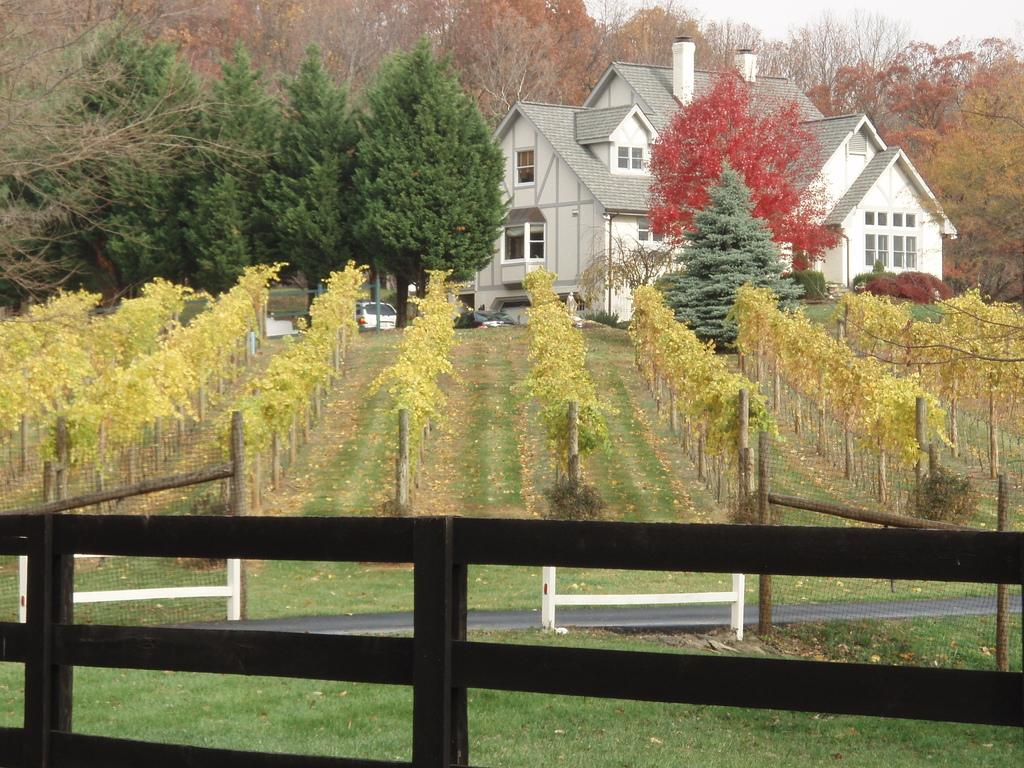What type of vegetation is present in the image? There is grass, plants, and trees in the image. What structures can be seen in the image? There are fences and a building with windows in the image. What else is visible in the image? There are vehicles and the sky in the background of the image. What type of silk is being used to create the mind-reading partner in the image? There is no silk, mind-reading, or partner present in the image. 